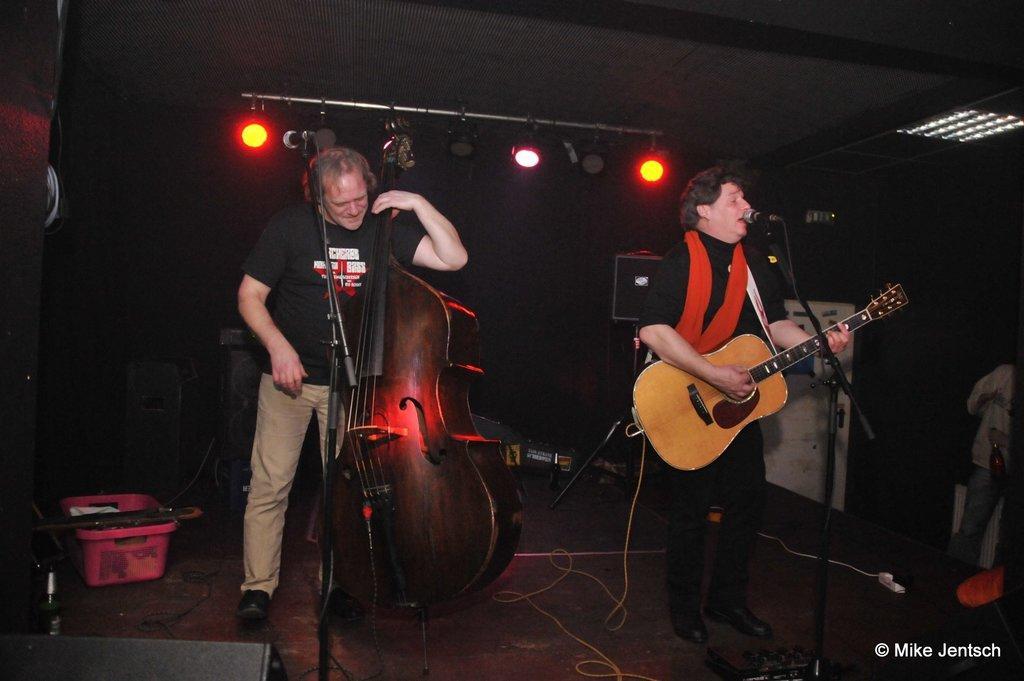In one or two sentences, can you explain what this image depicts? A man is singing while playing guitar. There is a man beside her is playing cello. There are some musical instruments beside them. There are some lights on the top. There are some people around them. 